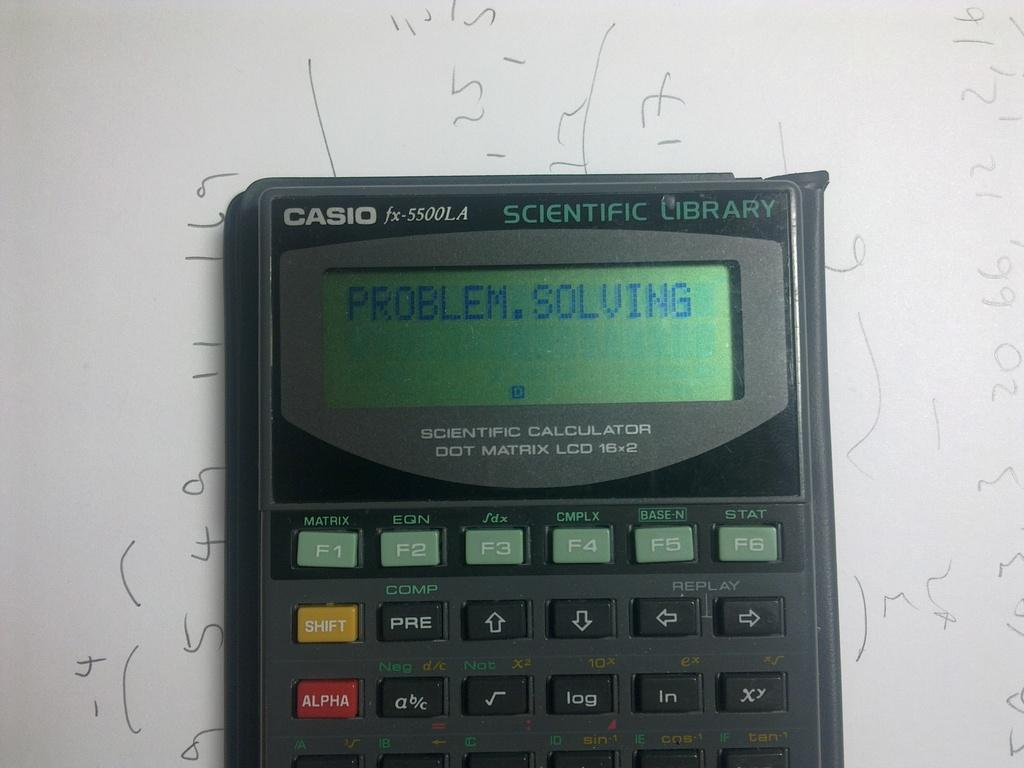<image>
Share a concise interpretation of the image provided. A Casio calculator says "Problem Solving" on the screen. 